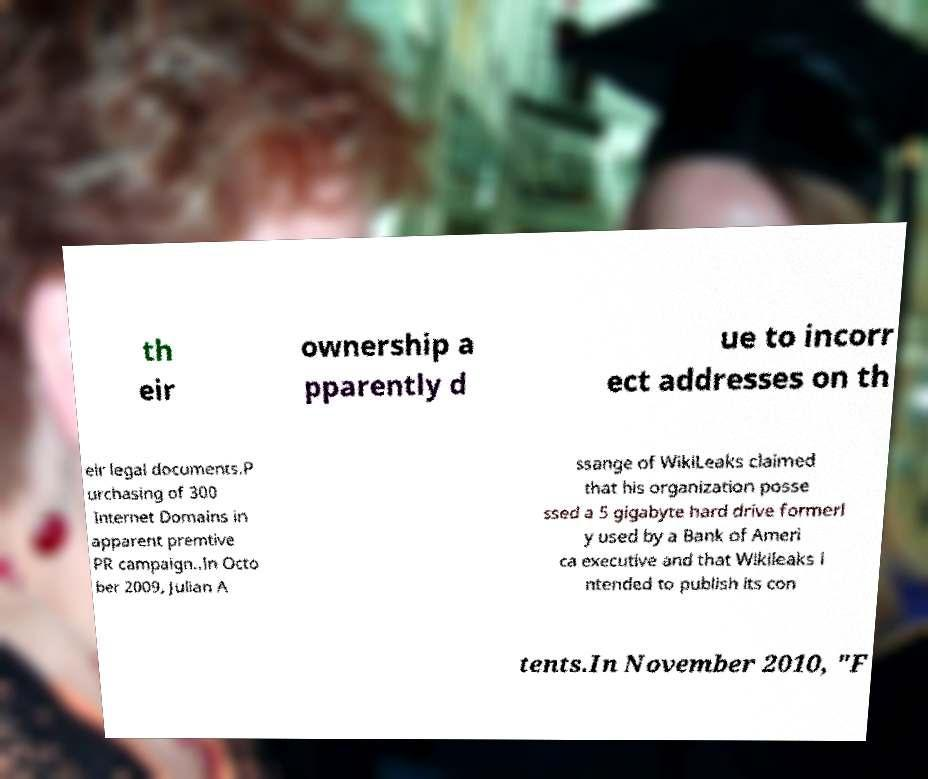Please identify and transcribe the text found in this image. th eir ownership a pparently d ue to incorr ect addresses on th eir legal documents.P urchasing of 300 Internet Domains in apparent premtive PR campaign..In Octo ber 2009, Julian A ssange of WikiLeaks claimed that his organization posse ssed a 5 gigabyte hard drive formerl y used by a Bank of Ameri ca executive and that Wikileaks i ntended to publish its con tents.In November 2010, "F 